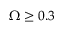Convert formula to latex. <formula><loc_0><loc_0><loc_500><loc_500>\Omega \geq 0 . 3</formula> 